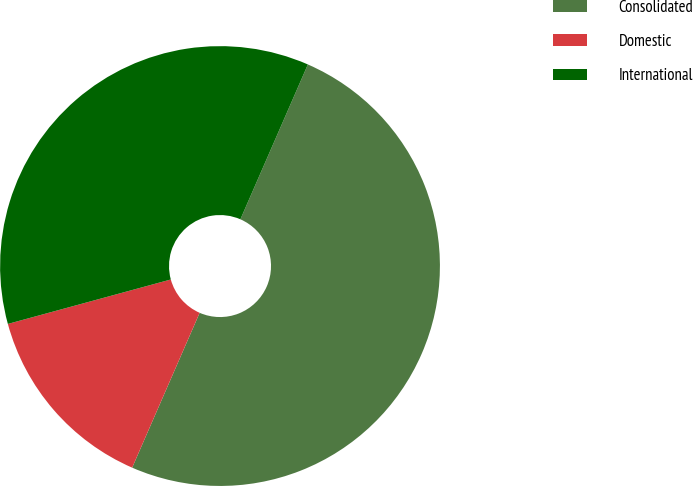Convert chart to OTSL. <chart><loc_0><loc_0><loc_500><loc_500><pie_chart><fcel>Consolidated<fcel>Domestic<fcel>International<nl><fcel>50.0%<fcel>14.22%<fcel>35.78%<nl></chart> 